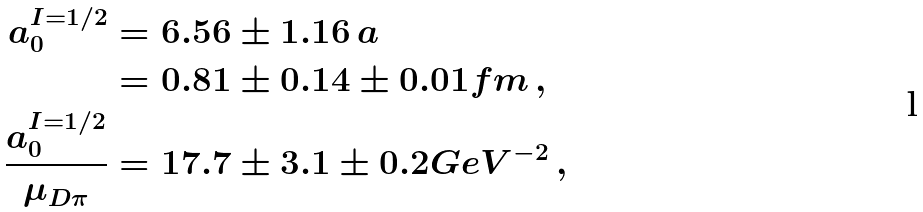Convert formula to latex. <formula><loc_0><loc_0><loc_500><loc_500>a ^ { I = 1 / 2 } _ { 0 } & = 6 . 5 6 \pm 1 . 1 6 \, a \\ & = 0 . 8 1 \pm 0 . 1 4 \pm 0 . 0 1 f m \, , \\ \frac { a ^ { I = 1 / 2 } _ { 0 } } { \mu _ { D \pi } } & = 1 7 . 7 \pm 3 . 1 \pm 0 . 2 G e V ^ { - 2 } \, ,</formula> 